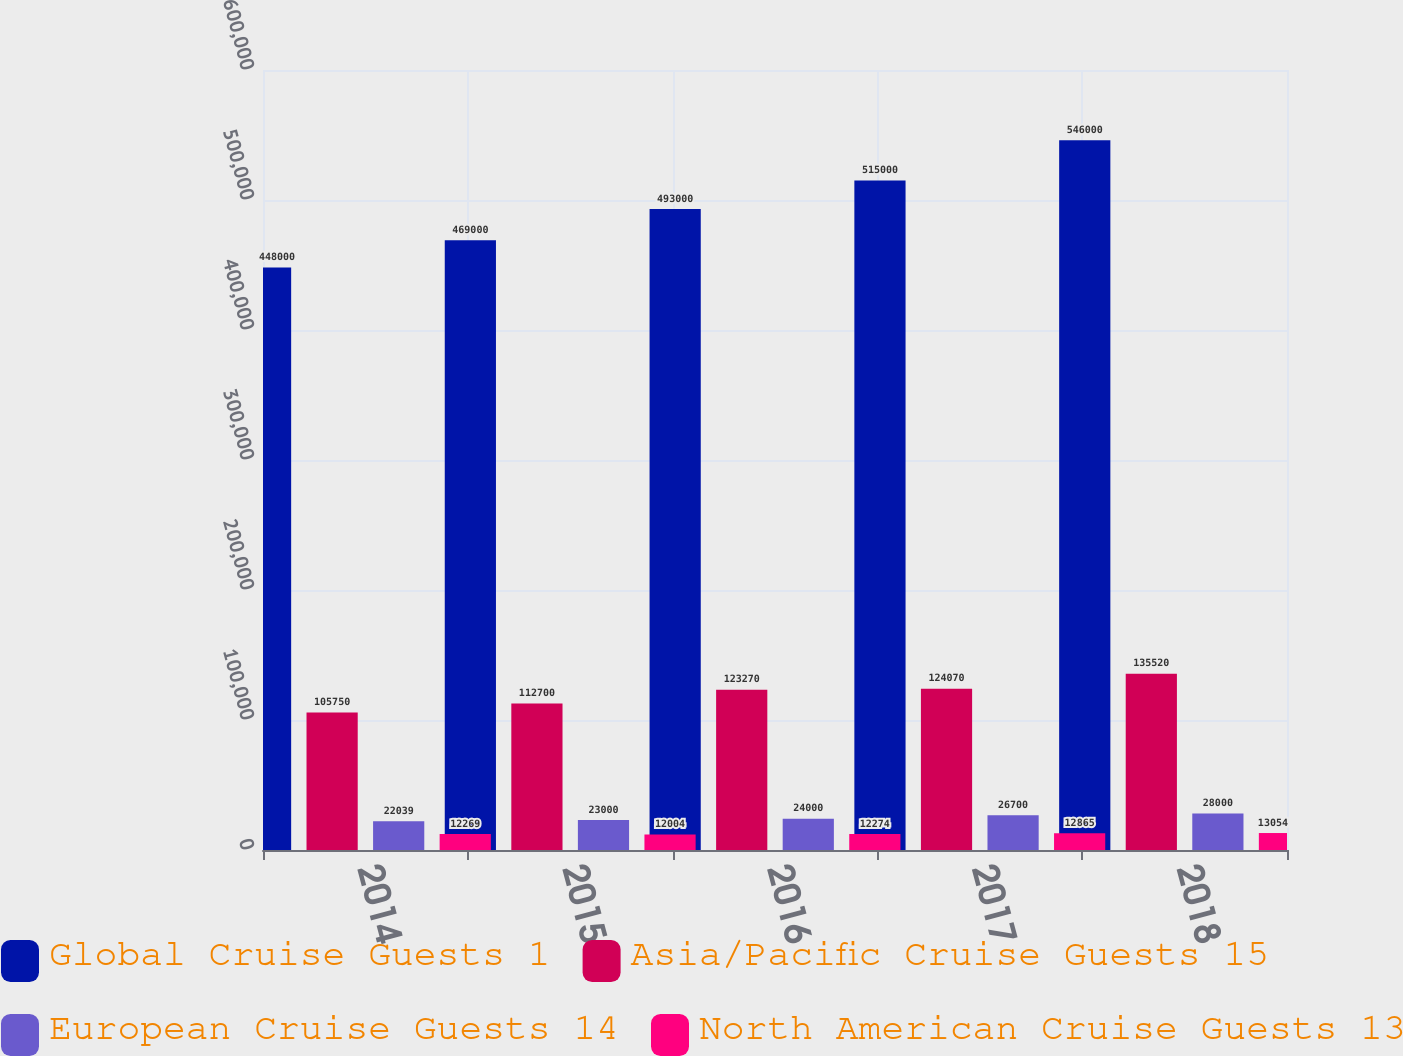Convert chart. <chart><loc_0><loc_0><loc_500><loc_500><stacked_bar_chart><ecel><fcel>2014<fcel>2015<fcel>2016<fcel>2017<fcel>2018<nl><fcel>Global Cruise Guests 1<fcel>448000<fcel>469000<fcel>493000<fcel>515000<fcel>546000<nl><fcel>Asia/Pacific Cruise Guests 15<fcel>105750<fcel>112700<fcel>123270<fcel>124070<fcel>135520<nl><fcel>European Cruise Guests 14<fcel>22039<fcel>23000<fcel>24000<fcel>26700<fcel>28000<nl><fcel>North American Cruise Guests 13<fcel>12269<fcel>12004<fcel>12274<fcel>12865<fcel>13054<nl></chart> 